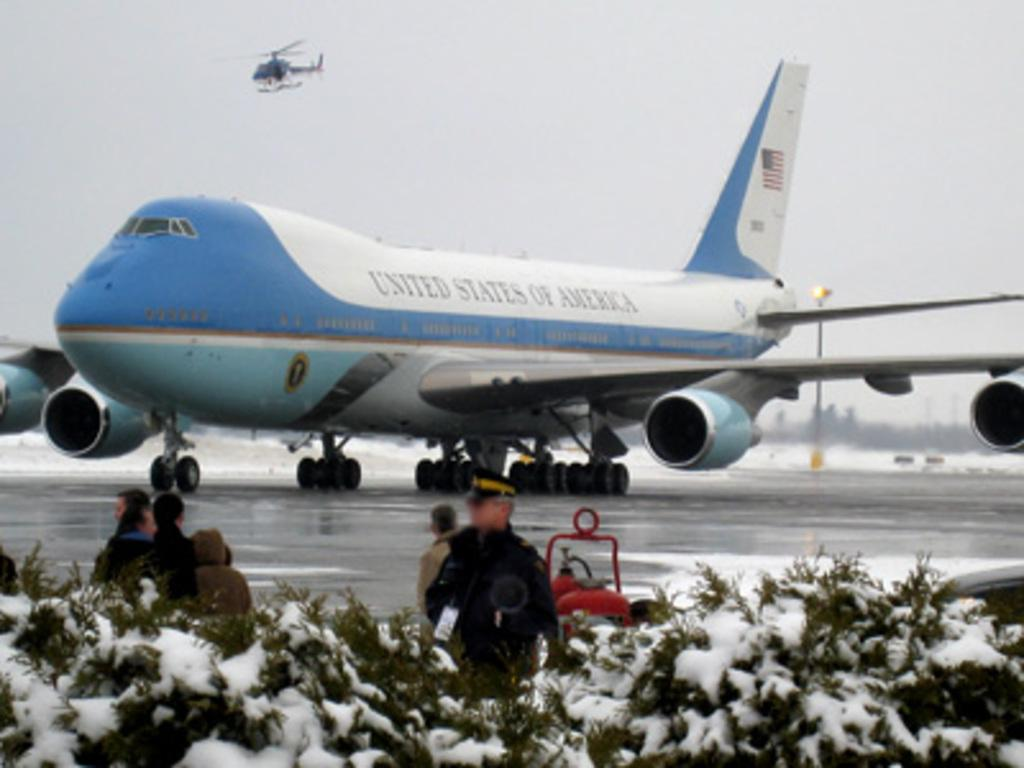<image>
Offer a succinct explanation of the picture presented. An airplane with United States of America written on the side sits on a runway. 